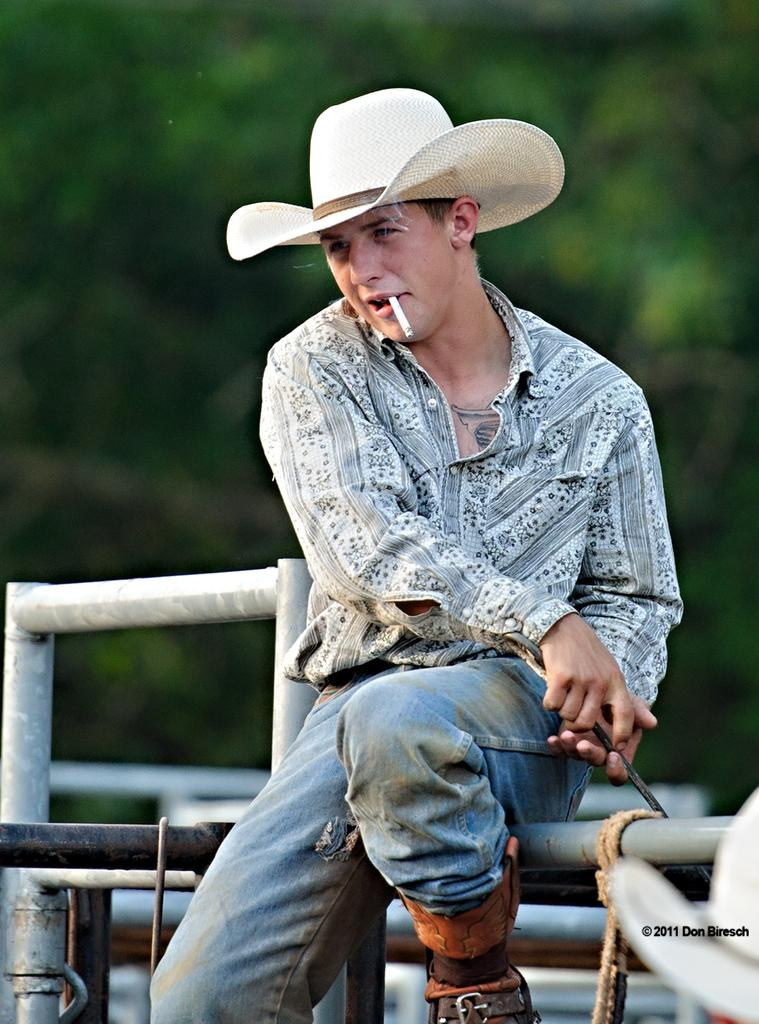What is the man in the image doing? The man is sitting in the image. What type of headwear is the man wearing? The man is wearing a cap. Can you describe the background of the image? The background of the image is blurry. What material can be seen in the image? Metal rods are visible in the image. What type of trade is the man conducting in the image? There is no indication of any trade in the image; the man is simply sitting. What observation can be made about the man's hammer in the image? There is no hammer present in the image. 